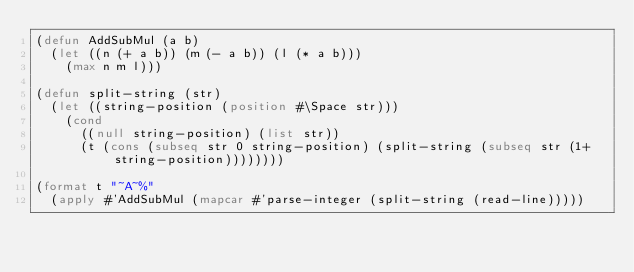<code> <loc_0><loc_0><loc_500><loc_500><_Lisp_>(defun AddSubMul (a b)
  (let ((n (+ a b)) (m (- a b)) (l (* a b)))
    (max n m l)))

(defun split-string (str)
  (let ((string-position (position #\Space str)))
    (cond
      ((null string-position) (list str))
      (t (cons (subseq str 0 string-position) (split-string (subseq str (1+ string-position))))))))

(format t "~A~%" 
  (apply #'AddSubMul (mapcar #'parse-integer (split-string (read-line)))))</code> 